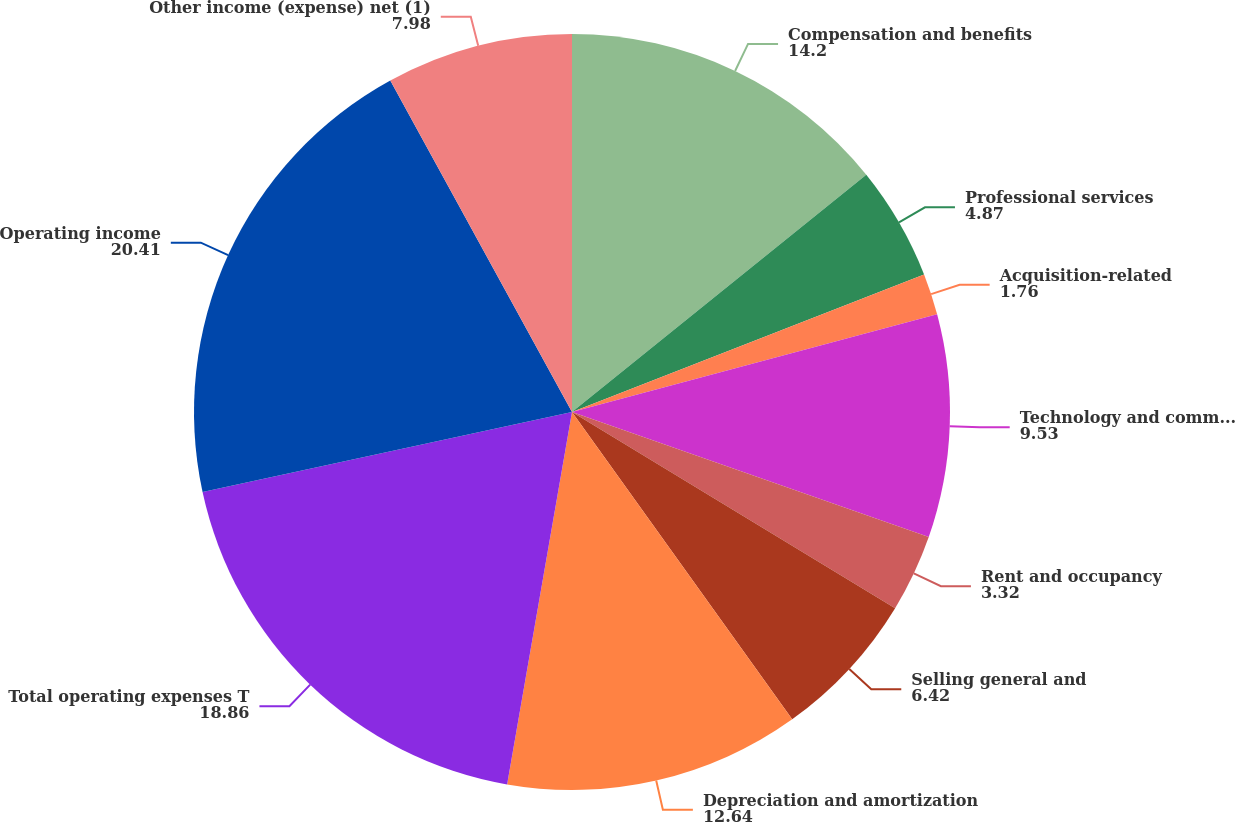Convert chart. <chart><loc_0><loc_0><loc_500><loc_500><pie_chart><fcel>Compensation and benefits<fcel>Professional services<fcel>Acquisition-related<fcel>Technology and communication<fcel>Rent and occupancy<fcel>Selling general and<fcel>Depreciation and amortization<fcel>Total operating expenses T<fcel>Operating income<fcel>Other income (expense) net (1)<nl><fcel>14.2%<fcel>4.87%<fcel>1.76%<fcel>9.53%<fcel>3.32%<fcel>6.42%<fcel>12.64%<fcel>18.86%<fcel>20.41%<fcel>7.98%<nl></chart> 